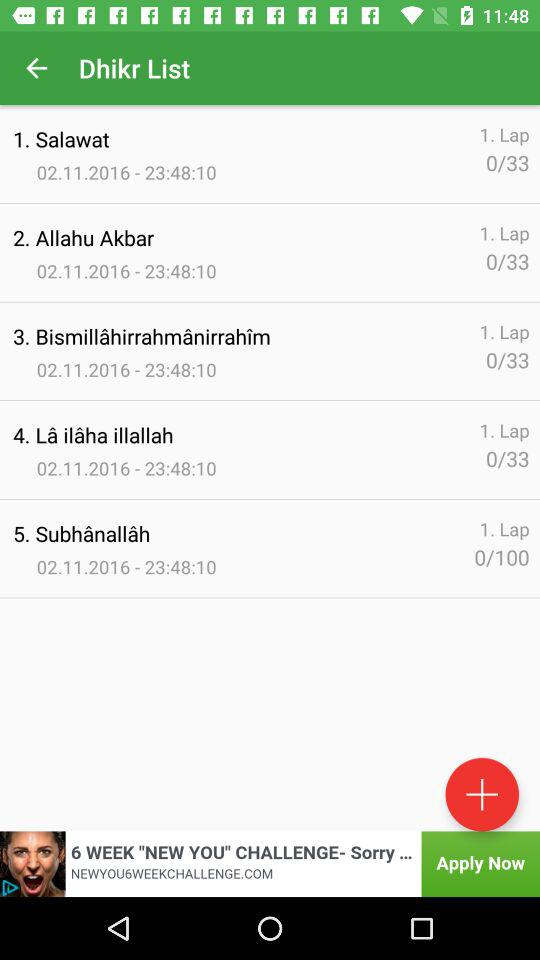What is the date of "Salawat"? The date is 02.11.2016. 